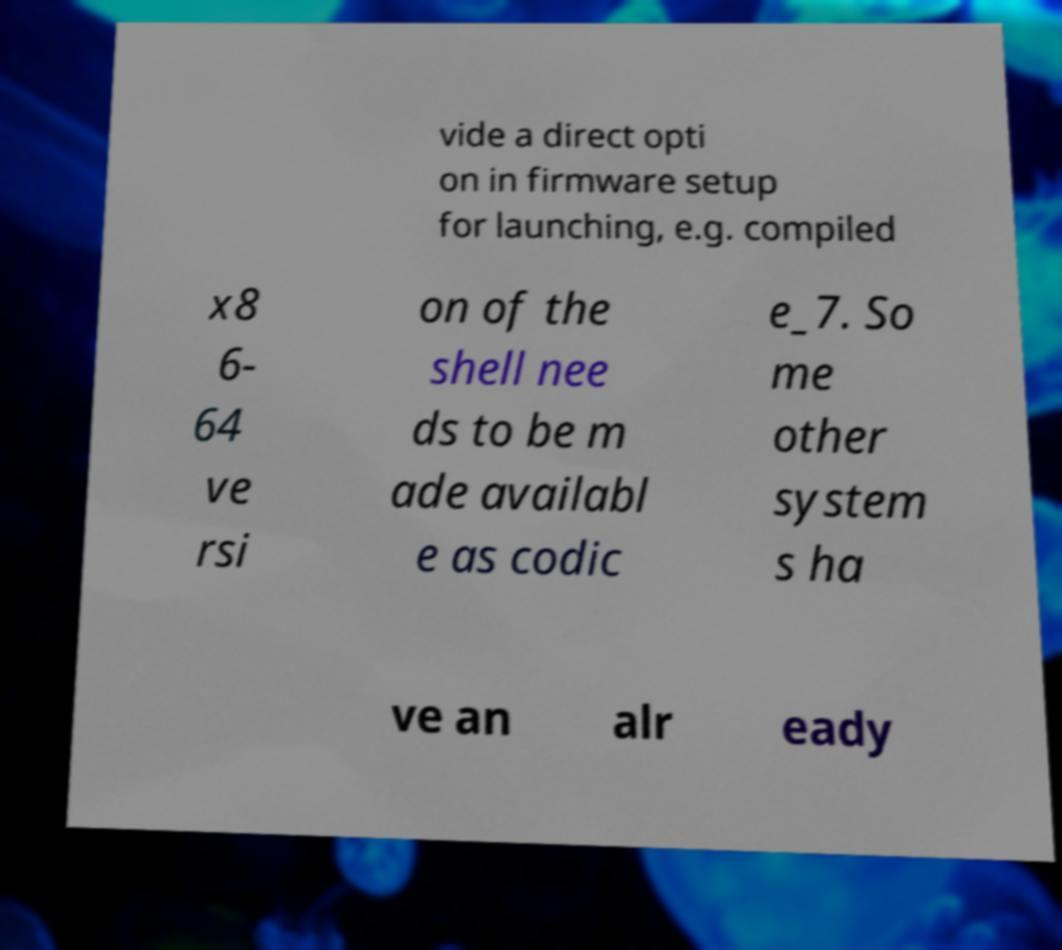Can you accurately transcribe the text from the provided image for me? vide a direct opti on in firmware setup for launching, e.g. compiled x8 6- 64 ve rsi on of the shell nee ds to be m ade availabl e as codic e_7. So me other system s ha ve an alr eady 